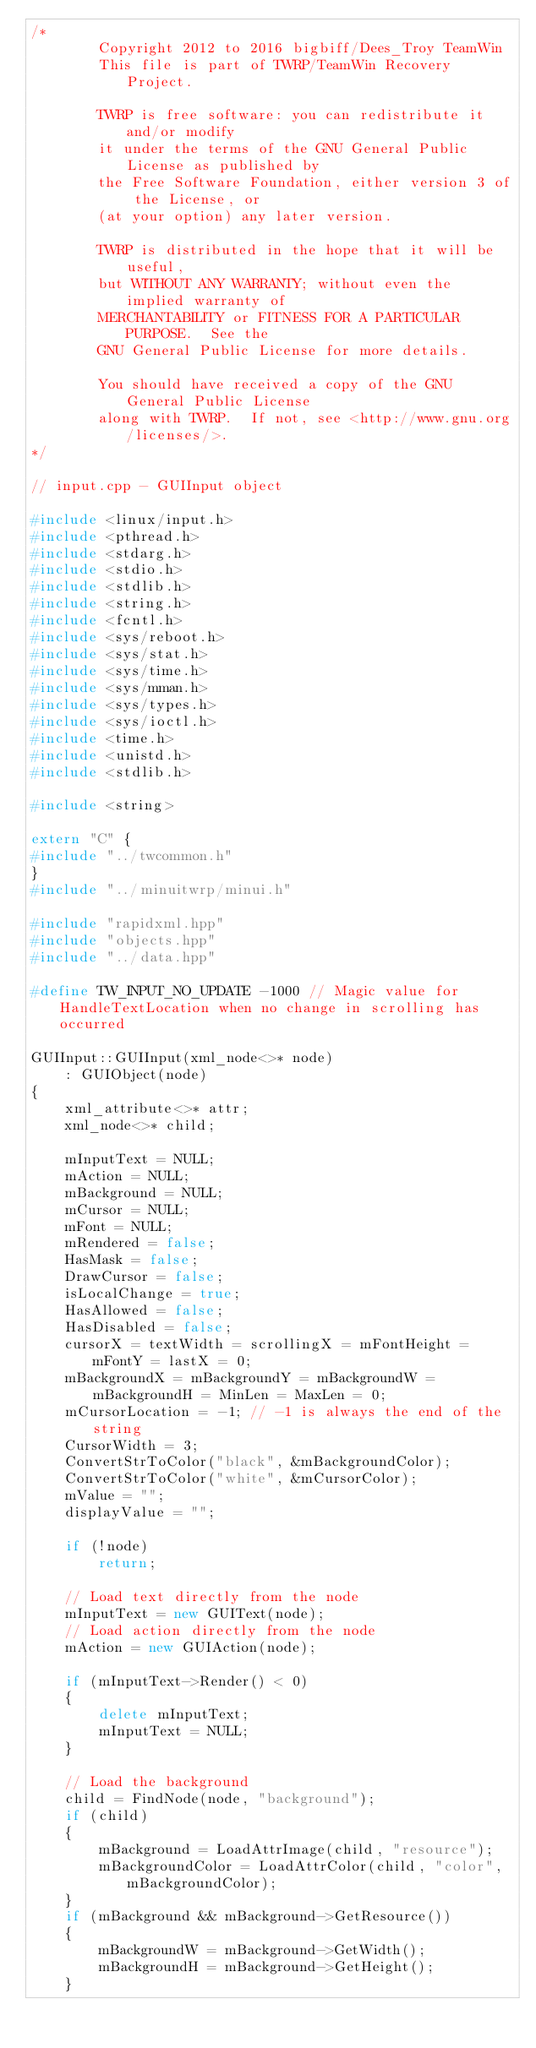Convert code to text. <code><loc_0><loc_0><loc_500><loc_500><_C++_>/*
        Copyright 2012 to 2016 bigbiff/Dees_Troy TeamWin
        This file is part of TWRP/TeamWin Recovery Project.

        TWRP is free software: you can redistribute it and/or modify
        it under the terms of the GNU General Public License as published by
        the Free Software Foundation, either version 3 of the License, or
        (at your option) any later version.

        TWRP is distributed in the hope that it will be useful,
        but WITHOUT ANY WARRANTY; without even the implied warranty of
        MERCHANTABILITY or FITNESS FOR A PARTICULAR PURPOSE.  See the
        GNU General Public License for more details.

        You should have received a copy of the GNU General Public License
        along with TWRP.  If not, see <http://www.gnu.org/licenses/>.
*/

// input.cpp - GUIInput object

#include <linux/input.h>
#include <pthread.h>
#include <stdarg.h>
#include <stdio.h>
#include <stdlib.h>
#include <string.h>
#include <fcntl.h>
#include <sys/reboot.h>
#include <sys/stat.h>
#include <sys/time.h>
#include <sys/mman.h>
#include <sys/types.h>
#include <sys/ioctl.h>
#include <time.h>
#include <unistd.h>
#include <stdlib.h>

#include <string>

extern "C" {
#include "../twcommon.h"
}
#include "../minuitwrp/minui.h"

#include "rapidxml.hpp"
#include "objects.hpp"
#include "../data.hpp"

#define TW_INPUT_NO_UPDATE -1000 // Magic value for HandleTextLocation when no change in scrolling has occurred

GUIInput::GUIInput(xml_node<>* node)
	: GUIObject(node)
{
	xml_attribute<>* attr;
	xml_node<>* child;

	mInputText = NULL;
	mAction = NULL;
	mBackground = NULL;
	mCursor = NULL;
	mFont = NULL;
	mRendered = false;
	HasMask = false;
	DrawCursor = false;
	isLocalChange = true;
	HasAllowed = false;
	HasDisabled = false;
	cursorX = textWidth = scrollingX = mFontHeight = mFontY = lastX = 0;
	mBackgroundX = mBackgroundY = mBackgroundW = mBackgroundH = MinLen = MaxLen = 0;
	mCursorLocation = -1; // -1 is always the end of the string
	CursorWidth = 3;
	ConvertStrToColor("black", &mBackgroundColor);
	ConvertStrToColor("white", &mCursorColor);
	mValue = "";
	displayValue = "";

	if (!node)
		return;

	// Load text directly from the node
	mInputText = new GUIText(node);
	// Load action directly from the node
	mAction = new GUIAction(node);

	if (mInputText->Render() < 0)
	{
		delete mInputText;
		mInputText = NULL;
	}

	// Load the background
	child = FindNode(node, "background");
	if (child)
	{
		mBackground = LoadAttrImage(child, "resource");
		mBackgroundColor = LoadAttrColor(child, "color", mBackgroundColor);
	}
	if (mBackground && mBackground->GetResource())
	{
		mBackgroundW = mBackground->GetWidth();
		mBackgroundH = mBackground->GetHeight();
	}
</code> 